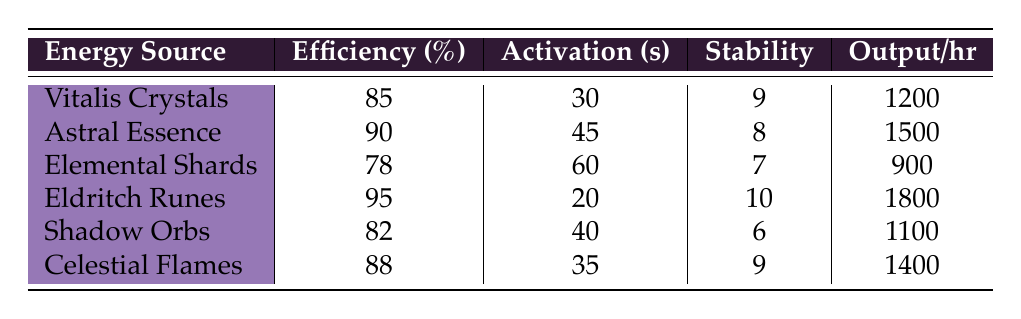What is the efficiency percentage of Eldritch Runes? The table shows that the efficiency percentage for Eldritch Runes is listed in the second row under the Efficiency column. It states that Eldritch Runes have an efficiency of 95%.
Answer: 95% Which energy source has the highest energy output per hour? By examining the energy output per hour column, Eldritch Runes is the first source with 1800 energy output per hour, which is more than the others listed.
Answer: Eldritch Runes What is the average activation time in seconds for all the energy sources? To find the average activation time, sum the activation times (30 + 45 + 60 + 20 + 40 + 35 = 230 seconds) and divide by the number of sources (6). Thus, the average activation time is 230/6 = 38.33 seconds.
Answer: 38.33 seconds Is the efficiency of Astral Essence greater than that of Shadow Orbs? The efficiency percentage for Astral Essence is 90% and for Shadow Orbs it's 82%. Since 90 is greater than 82, the statement is true.
Answer: Yes Which arcane energy source has both the highest stability score and efficiency? Checking the stability and efficiency scores, Eldritch Runes has the highest efficiency (95%) and stability score (10) among all listed energy sources, standing out as the best in both categories.
Answer: Eldritch Runes What is the difference in energy output per hour between Elemental Shards and Vitalis Crystals? Energy output for Elemental Shards is noted as 900 and for Vitalis Crystals as 1200 in the table. The difference is calculated as 1200 - 900 = 300 energy output per hour.
Answer: 300 How many energy sources have an efficiency percentage above 85%? By scanning the efficiency percentages in the table (85, 90, 78, 95, 82, 88), we find that those above 85% are Astral Essence (90), Eldritch Runes (95), and Celestial Flames (88). That's a total of 3 energy sources.
Answer: 3 What is the stability score of the energy source with the lowest efficiency percentage? The lowest efficiency percentage is for Elemental Shards (78%). Under the stability score column, it shows a score of 7 for this source.
Answer: 7 How long does it take to activate the energy source with the highest efficiency? The energy source with the highest efficiency is Eldritch Runes, which has an activation time of 20 seconds as per the table.
Answer: 20 seconds If you were to rank the energy sources based on their efficiency from highest to lowest, what position would Shadow Orbs occupy? Shadow Orbs has an efficiency of 82%, which, when compared to other energies (95, 90, 88, 85, and 78), places it in the 4th position after Eldritch Runes, Astral Essence, and Celestial Flames, but before Elemental Shards.
Answer: 4th position 